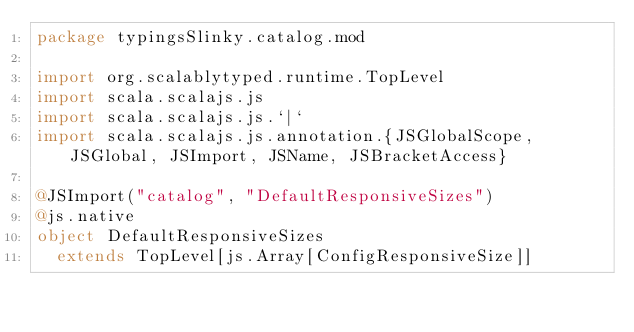<code> <loc_0><loc_0><loc_500><loc_500><_Scala_>package typingsSlinky.catalog.mod

import org.scalablytyped.runtime.TopLevel
import scala.scalajs.js
import scala.scalajs.js.`|`
import scala.scalajs.js.annotation.{JSGlobalScope, JSGlobal, JSImport, JSName, JSBracketAccess}

@JSImport("catalog", "DefaultResponsiveSizes")
@js.native
object DefaultResponsiveSizes
  extends TopLevel[js.Array[ConfigResponsiveSize]]
</code> 